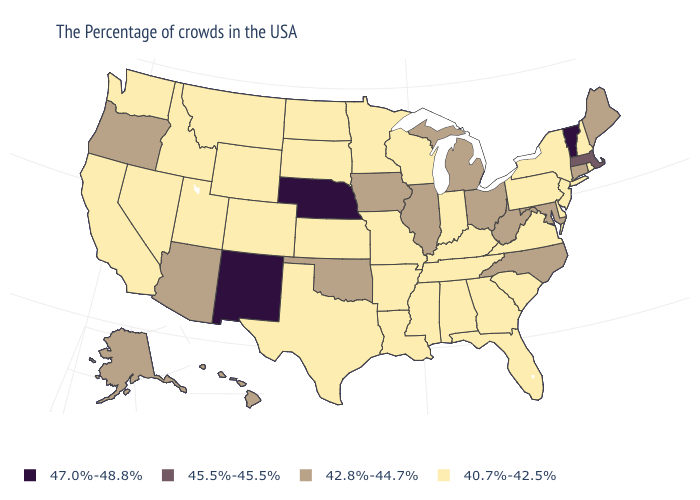What is the highest value in the USA?
Be succinct. 47.0%-48.8%. What is the value of Wyoming?
Give a very brief answer. 40.7%-42.5%. Among the states that border Washington , does Oregon have the lowest value?
Be succinct. No. Name the states that have a value in the range 40.7%-42.5%?
Answer briefly. Rhode Island, New Hampshire, New York, New Jersey, Delaware, Pennsylvania, Virginia, South Carolina, Florida, Georgia, Kentucky, Indiana, Alabama, Tennessee, Wisconsin, Mississippi, Louisiana, Missouri, Arkansas, Minnesota, Kansas, Texas, South Dakota, North Dakota, Wyoming, Colorado, Utah, Montana, Idaho, Nevada, California, Washington. What is the highest value in the USA?
Be succinct. 47.0%-48.8%. What is the value of Kansas?
Give a very brief answer. 40.7%-42.5%. Name the states that have a value in the range 47.0%-48.8%?
Concise answer only. Vermont, Nebraska, New Mexico. What is the highest value in states that border Ohio?
Quick response, please. 42.8%-44.7%. What is the value of New Jersey?
Short answer required. 40.7%-42.5%. Name the states that have a value in the range 47.0%-48.8%?
Give a very brief answer. Vermont, Nebraska, New Mexico. Does Nebraska have the highest value in the MidWest?
Be succinct. Yes. What is the lowest value in the MidWest?
Keep it brief. 40.7%-42.5%. Is the legend a continuous bar?
Be succinct. No. Among the states that border Colorado , does Utah have the highest value?
Keep it brief. No. Name the states that have a value in the range 42.8%-44.7%?
Give a very brief answer. Maine, Connecticut, Maryland, North Carolina, West Virginia, Ohio, Michigan, Illinois, Iowa, Oklahoma, Arizona, Oregon, Alaska, Hawaii. 